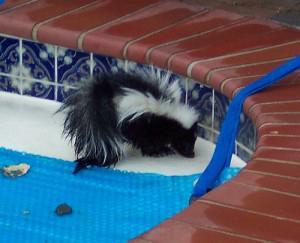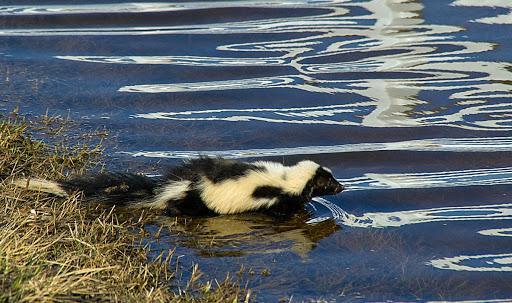The first image is the image on the left, the second image is the image on the right. Examine the images to the left and right. Is the description "The skunk in one of the images is sitting on a float in a pool, while in the other image it is swimming freely in the water." accurate? Answer yes or no. No. The first image is the image on the left, the second image is the image on the right. For the images shown, is this caption "In at least one image there is a skunk sitting on a blue raft in a pool." true? Answer yes or no. No. 